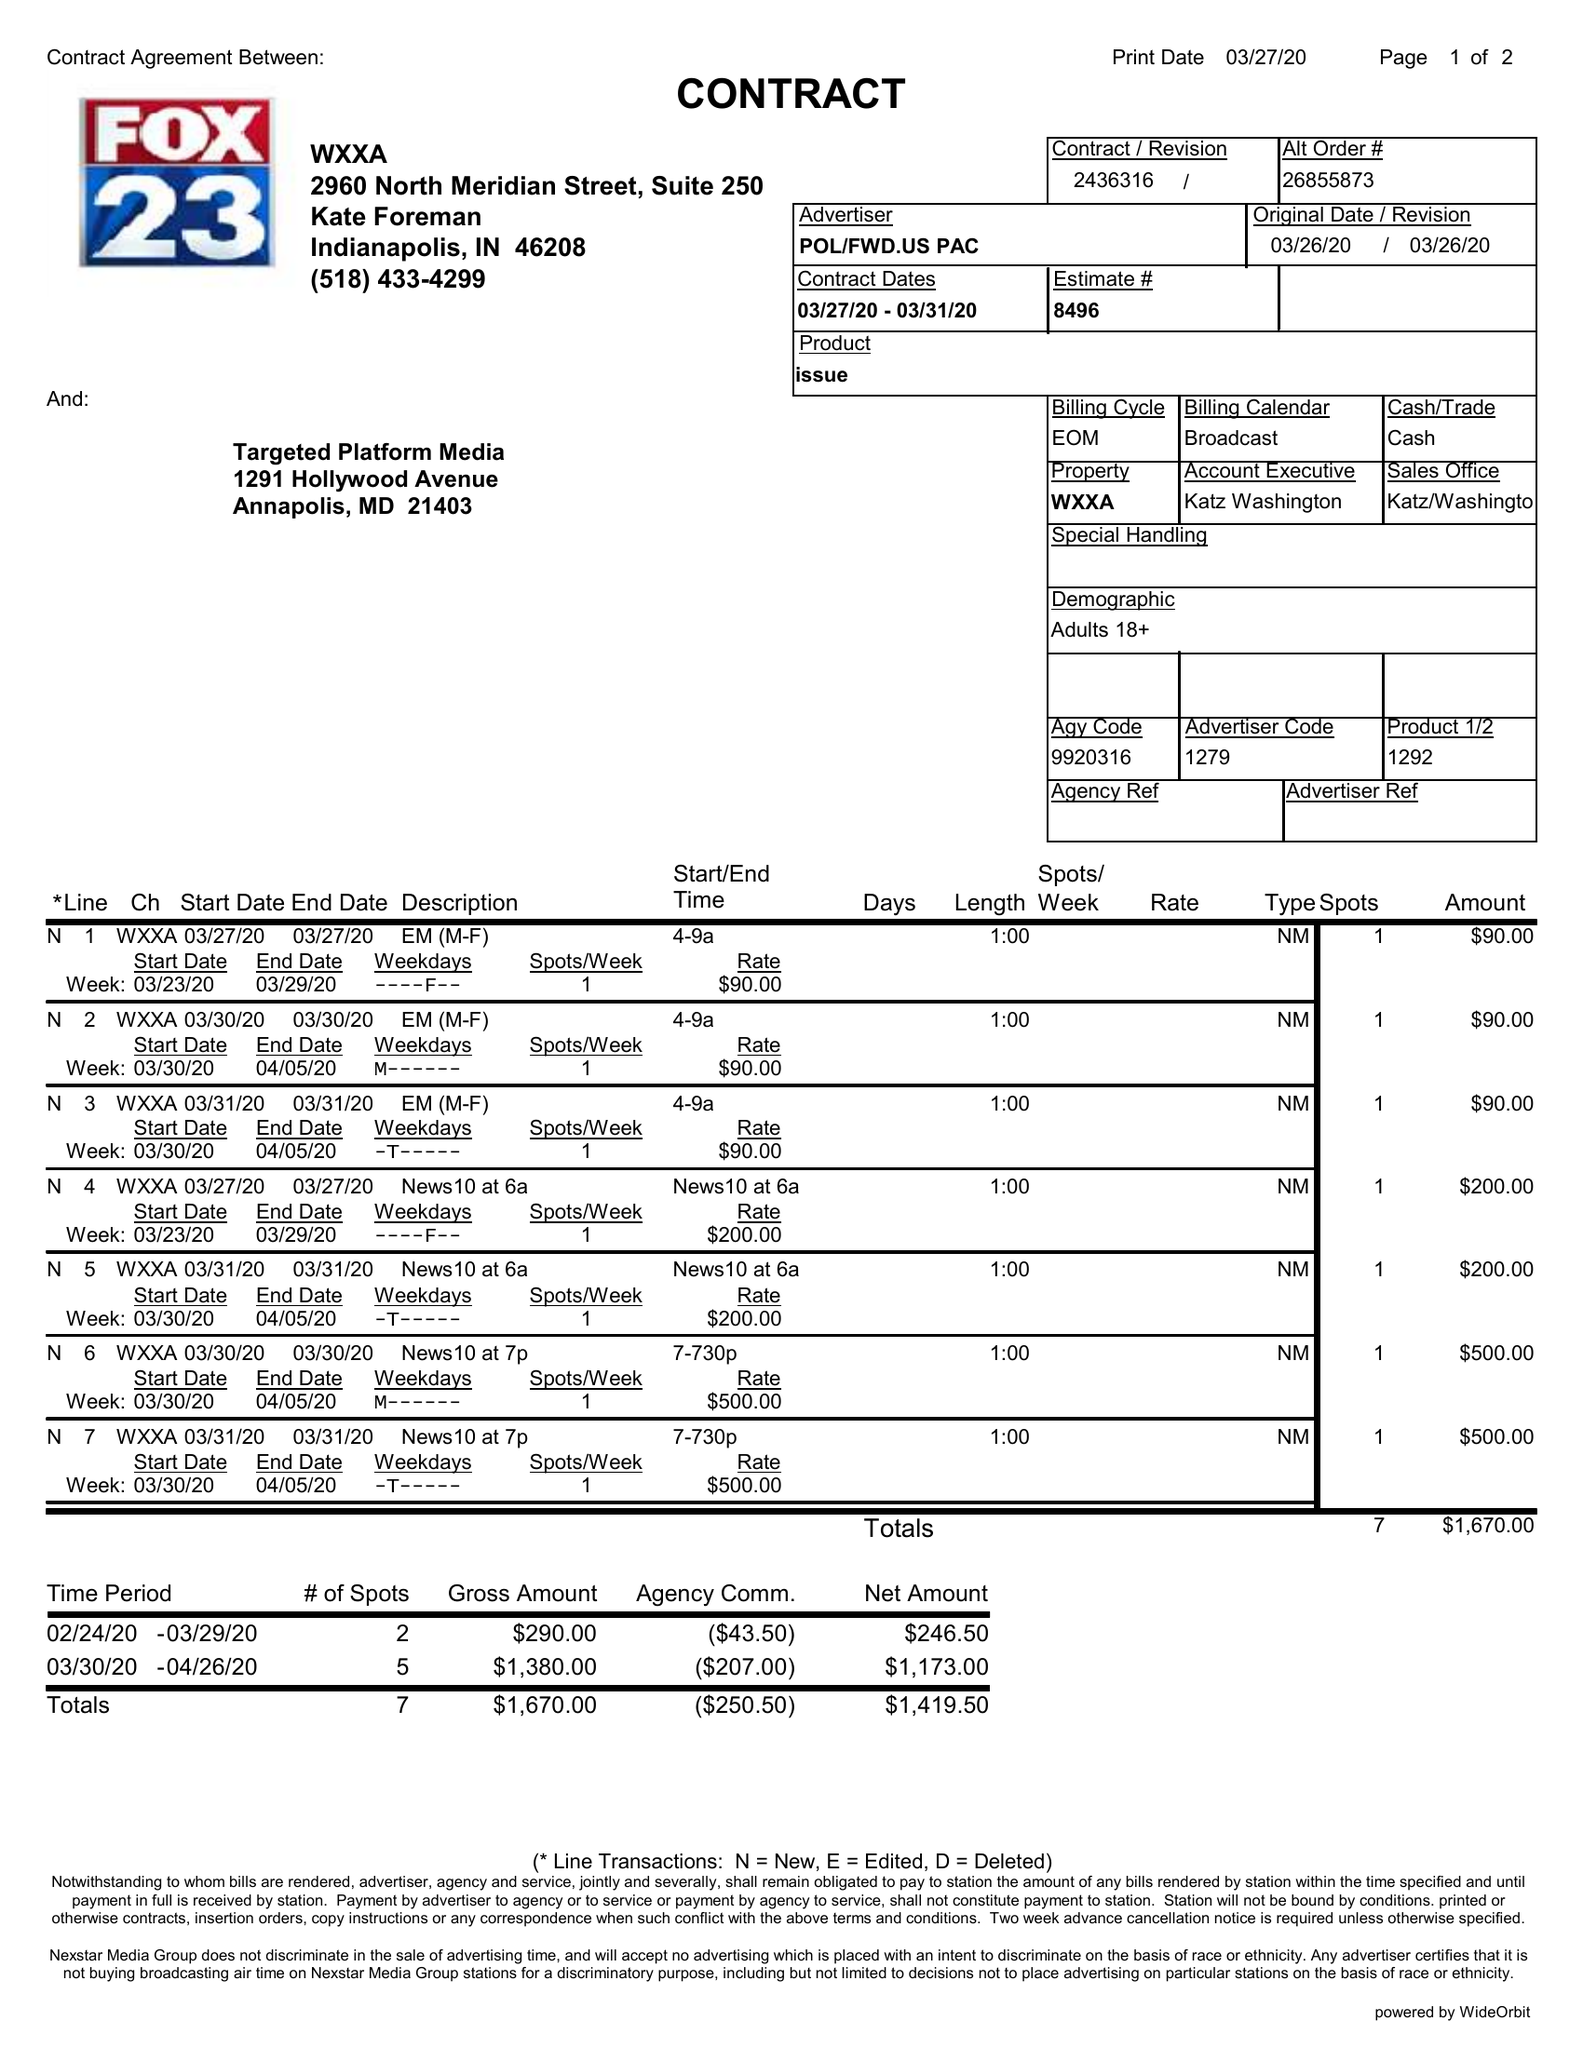What is the value for the flight_to?
Answer the question using a single word or phrase. 03/31/20 